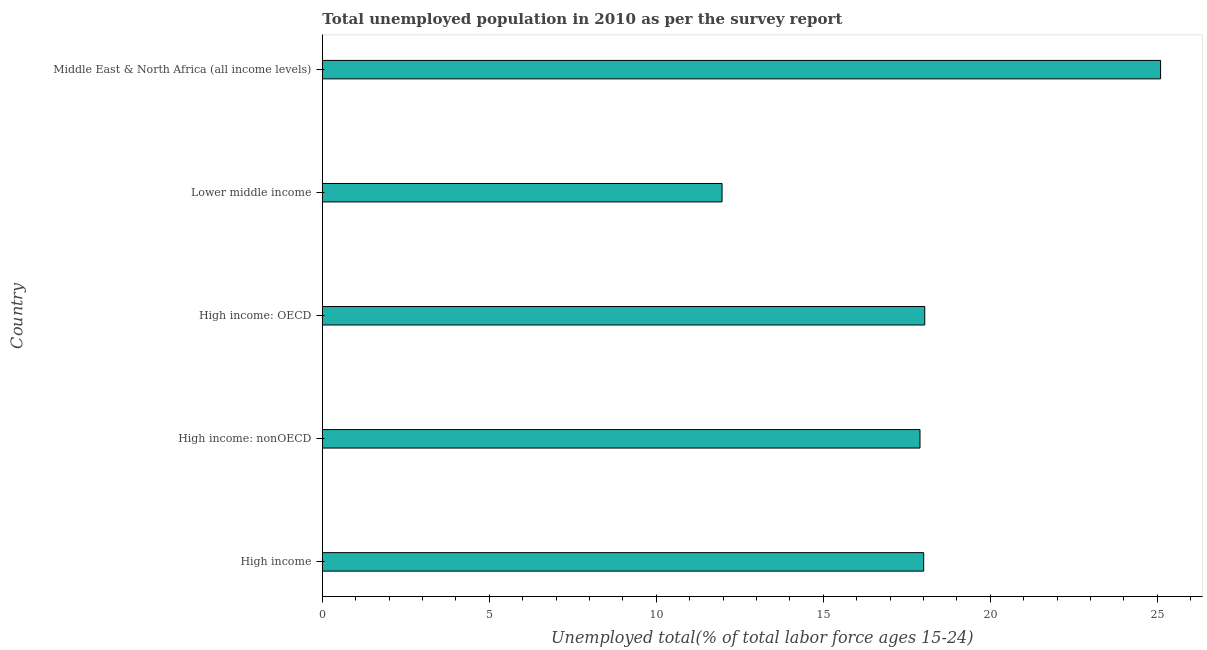Does the graph contain grids?
Ensure brevity in your answer.  No. What is the title of the graph?
Your response must be concise. Total unemployed population in 2010 as per the survey report. What is the label or title of the X-axis?
Make the answer very short. Unemployed total(% of total labor force ages 15-24). What is the unemployed youth in High income?
Offer a terse response. 18.01. Across all countries, what is the maximum unemployed youth?
Offer a very short reply. 25.1. Across all countries, what is the minimum unemployed youth?
Keep it short and to the point. 11.97. In which country was the unemployed youth maximum?
Offer a terse response. Middle East & North Africa (all income levels). In which country was the unemployed youth minimum?
Provide a succinct answer. Lower middle income. What is the sum of the unemployed youth?
Your answer should be very brief. 91.01. What is the difference between the unemployed youth in High income: nonOECD and Lower middle income?
Keep it short and to the point. 5.93. What is the average unemployed youth per country?
Provide a succinct answer. 18.2. What is the median unemployed youth?
Make the answer very short. 18.01. In how many countries, is the unemployed youth greater than 1 %?
Provide a short and direct response. 5. What is the ratio of the unemployed youth in Lower middle income to that in Middle East & North Africa (all income levels)?
Keep it short and to the point. 0.48. What is the difference between the highest and the second highest unemployed youth?
Keep it short and to the point. 7.06. What is the difference between the highest and the lowest unemployed youth?
Give a very brief answer. 13.13. In how many countries, is the unemployed youth greater than the average unemployed youth taken over all countries?
Ensure brevity in your answer.  1. How many countries are there in the graph?
Ensure brevity in your answer.  5. What is the difference between two consecutive major ticks on the X-axis?
Your answer should be very brief. 5. Are the values on the major ticks of X-axis written in scientific E-notation?
Ensure brevity in your answer.  No. What is the Unemployed total(% of total labor force ages 15-24) in High income?
Keep it short and to the point. 18.01. What is the Unemployed total(% of total labor force ages 15-24) in High income: nonOECD?
Provide a succinct answer. 17.9. What is the Unemployed total(% of total labor force ages 15-24) in High income: OECD?
Make the answer very short. 18.04. What is the Unemployed total(% of total labor force ages 15-24) in Lower middle income?
Your answer should be very brief. 11.97. What is the Unemployed total(% of total labor force ages 15-24) of Middle East & North Africa (all income levels)?
Offer a very short reply. 25.1. What is the difference between the Unemployed total(% of total labor force ages 15-24) in High income and High income: nonOECD?
Provide a short and direct response. 0.11. What is the difference between the Unemployed total(% of total labor force ages 15-24) in High income and High income: OECD?
Offer a terse response. -0.03. What is the difference between the Unemployed total(% of total labor force ages 15-24) in High income and Lower middle income?
Your answer should be very brief. 6.04. What is the difference between the Unemployed total(% of total labor force ages 15-24) in High income and Middle East & North Africa (all income levels)?
Make the answer very short. -7.09. What is the difference between the Unemployed total(% of total labor force ages 15-24) in High income: nonOECD and High income: OECD?
Provide a short and direct response. -0.14. What is the difference between the Unemployed total(% of total labor force ages 15-24) in High income: nonOECD and Lower middle income?
Your answer should be compact. 5.93. What is the difference between the Unemployed total(% of total labor force ages 15-24) in High income: nonOECD and Middle East & North Africa (all income levels)?
Offer a terse response. -7.2. What is the difference between the Unemployed total(% of total labor force ages 15-24) in High income: OECD and Lower middle income?
Your response must be concise. 6.07. What is the difference between the Unemployed total(% of total labor force ages 15-24) in High income: OECD and Middle East & North Africa (all income levels)?
Ensure brevity in your answer.  -7.06. What is the difference between the Unemployed total(% of total labor force ages 15-24) in Lower middle income and Middle East & North Africa (all income levels)?
Give a very brief answer. -13.13. What is the ratio of the Unemployed total(% of total labor force ages 15-24) in High income to that in High income: nonOECD?
Your answer should be compact. 1.01. What is the ratio of the Unemployed total(% of total labor force ages 15-24) in High income to that in Lower middle income?
Keep it short and to the point. 1.5. What is the ratio of the Unemployed total(% of total labor force ages 15-24) in High income to that in Middle East & North Africa (all income levels)?
Provide a short and direct response. 0.72. What is the ratio of the Unemployed total(% of total labor force ages 15-24) in High income: nonOECD to that in Lower middle income?
Give a very brief answer. 1.5. What is the ratio of the Unemployed total(% of total labor force ages 15-24) in High income: nonOECD to that in Middle East & North Africa (all income levels)?
Give a very brief answer. 0.71. What is the ratio of the Unemployed total(% of total labor force ages 15-24) in High income: OECD to that in Lower middle income?
Ensure brevity in your answer.  1.51. What is the ratio of the Unemployed total(% of total labor force ages 15-24) in High income: OECD to that in Middle East & North Africa (all income levels)?
Your answer should be compact. 0.72. What is the ratio of the Unemployed total(% of total labor force ages 15-24) in Lower middle income to that in Middle East & North Africa (all income levels)?
Give a very brief answer. 0.48. 